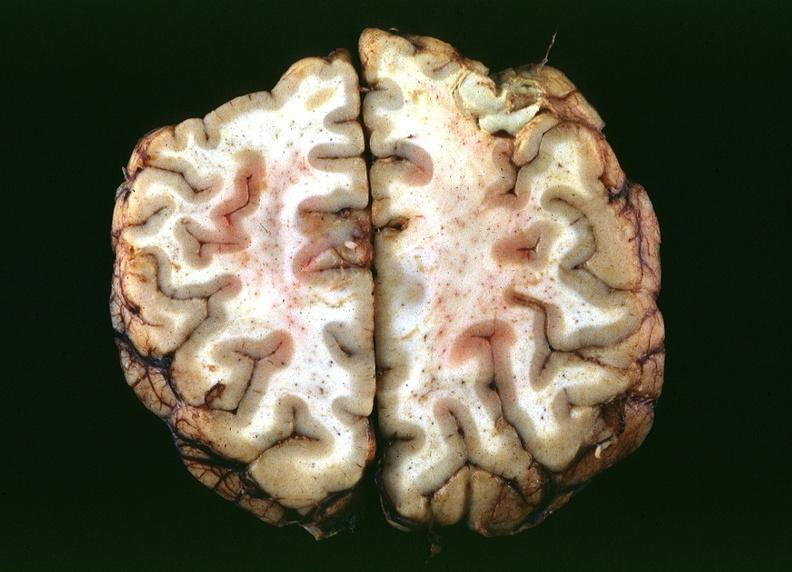s prostate present?
Answer the question using a single word or phrase. No 